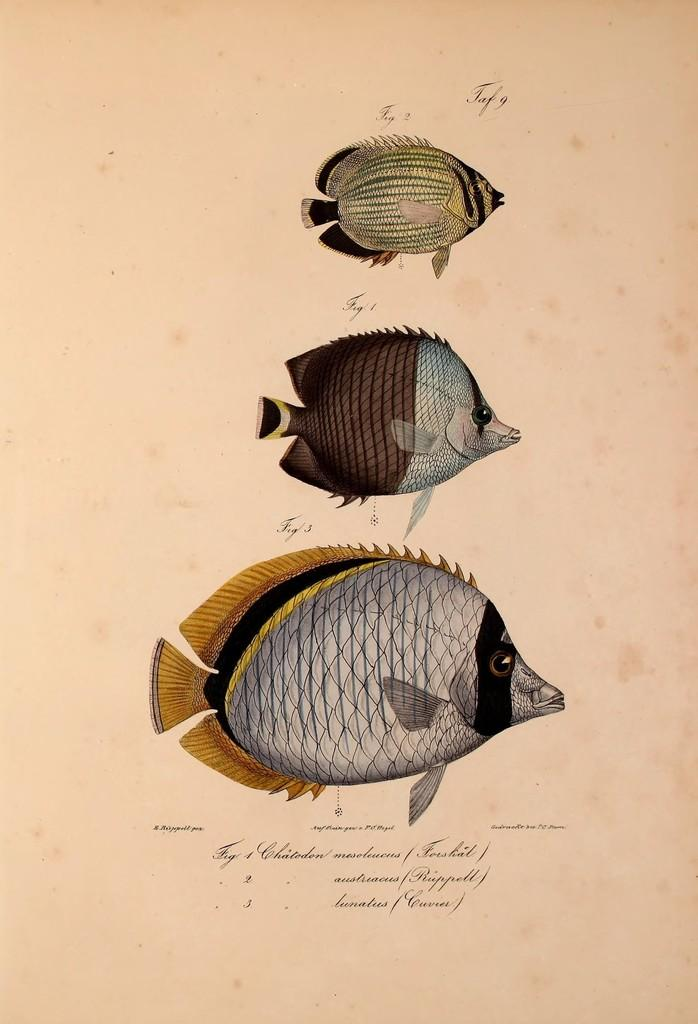How many fishes are drawn on the paper? There are three different sized fishes drawn on the paper. What can be found in addition to the fishes on the paper? Text is written on the paper. What color is the orange floating in the water next to the boat in the image? There is no orange or boat present in the image; it only features three different sized fishes drawn on a paper with text. 